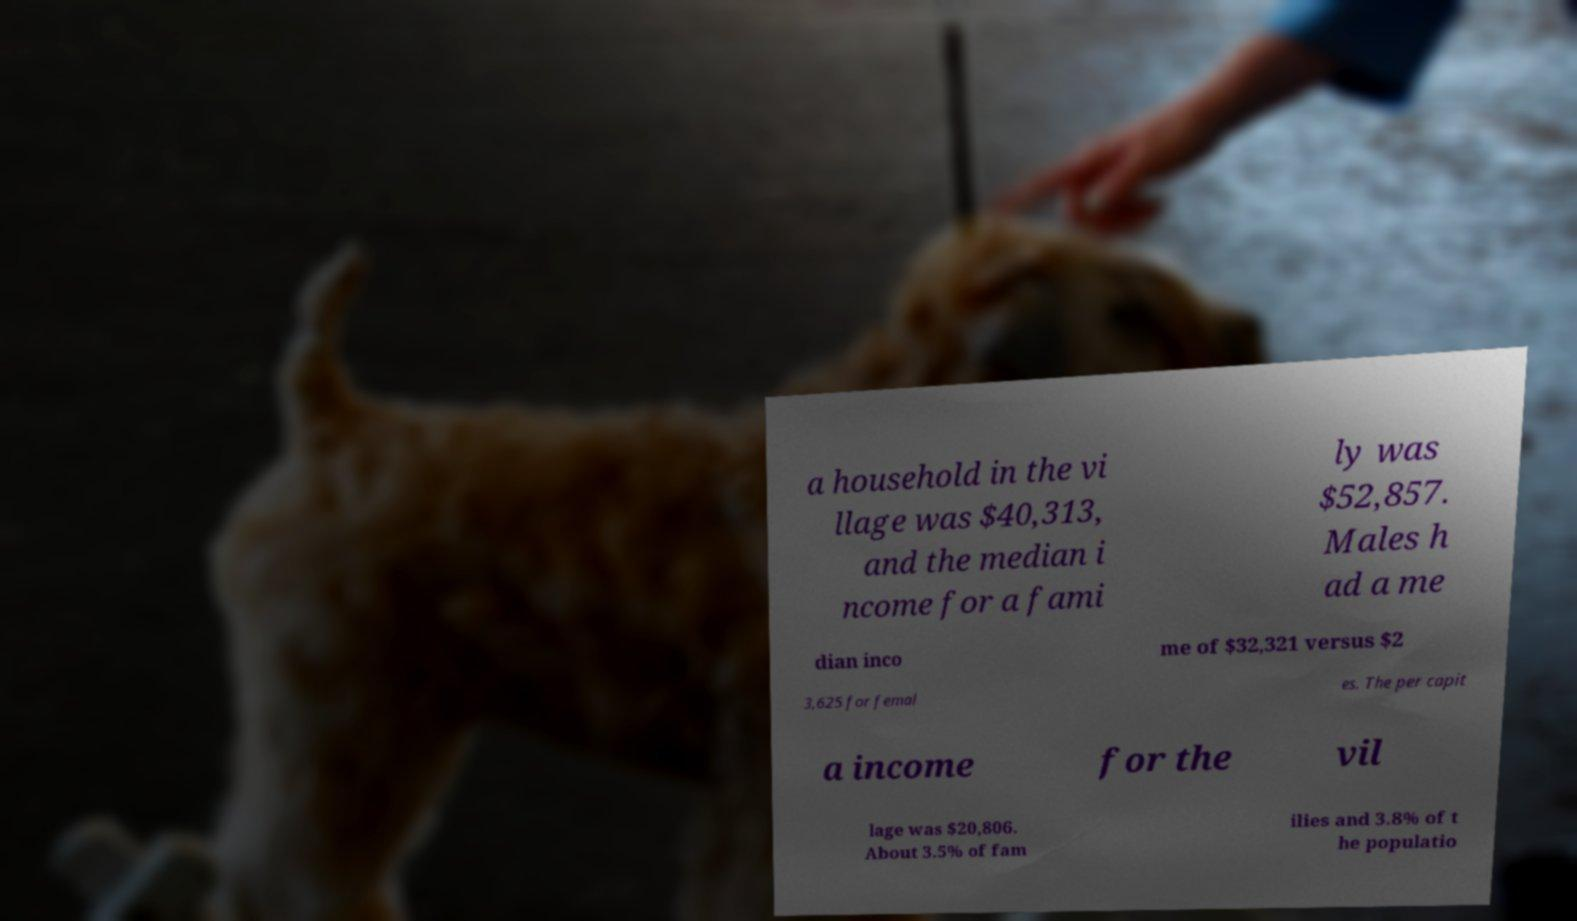Could you extract and type out the text from this image? a household in the vi llage was $40,313, and the median i ncome for a fami ly was $52,857. Males h ad a me dian inco me of $32,321 versus $2 3,625 for femal es. The per capit a income for the vil lage was $20,806. About 3.5% of fam ilies and 3.8% of t he populatio 